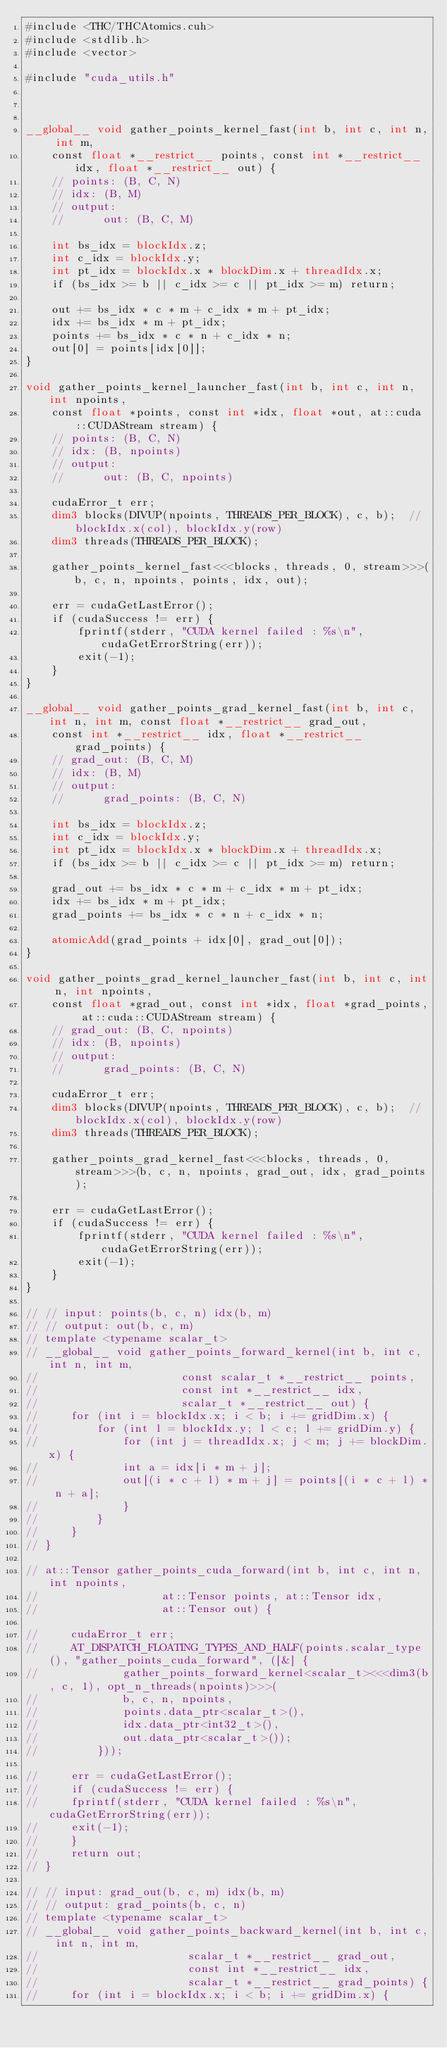Convert code to text. <code><loc_0><loc_0><loc_500><loc_500><_Cuda_>#include <THC/THCAtomics.cuh>
#include <stdlib.h>
#include <vector>

#include "cuda_utils.h"



__global__ void gather_points_kernel_fast(int b, int c, int n, int m,
    const float *__restrict__ points, const int *__restrict__ idx, float *__restrict__ out) {
    // points: (B, C, N)
    // idx: (B, M)
    // output:
    //      out: (B, C, M)

    int bs_idx = blockIdx.z;
    int c_idx = blockIdx.y;
    int pt_idx = blockIdx.x * blockDim.x + threadIdx.x;
    if (bs_idx >= b || c_idx >= c || pt_idx >= m) return;

    out += bs_idx * c * m + c_idx * m + pt_idx;
    idx += bs_idx * m + pt_idx;
    points += bs_idx * c * n + c_idx * n;
    out[0] = points[idx[0]];
}

void gather_points_kernel_launcher_fast(int b, int c, int n, int npoints,
    const float *points, const int *idx, float *out, at::cuda::CUDAStream stream) {
    // points: (B, C, N)
    // idx: (B, npoints)
    // output:
    //      out: (B, C, npoints)

    cudaError_t err;
    dim3 blocks(DIVUP(npoints, THREADS_PER_BLOCK), c, b);  // blockIdx.x(col), blockIdx.y(row)
    dim3 threads(THREADS_PER_BLOCK);

    gather_points_kernel_fast<<<blocks, threads, 0, stream>>>(b, c, n, npoints, points, idx, out);

    err = cudaGetLastError();
    if (cudaSuccess != err) {
        fprintf(stderr, "CUDA kernel failed : %s\n", cudaGetErrorString(err));
        exit(-1);
    }
}

__global__ void gather_points_grad_kernel_fast(int b, int c, int n, int m, const float *__restrict__ grad_out,
    const int *__restrict__ idx, float *__restrict__ grad_points) {
    // grad_out: (B, C, M)
    // idx: (B, M)
    // output:
    //      grad_points: (B, C, N)

    int bs_idx = blockIdx.z;
    int c_idx = blockIdx.y;
    int pt_idx = blockIdx.x * blockDim.x + threadIdx.x;
    if (bs_idx >= b || c_idx >= c || pt_idx >= m) return;

    grad_out += bs_idx * c * m + c_idx * m + pt_idx;
    idx += bs_idx * m + pt_idx;
    grad_points += bs_idx * c * n + c_idx * n;

    atomicAdd(grad_points + idx[0], grad_out[0]);
}

void gather_points_grad_kernel_launcher_fast(int b, int c, int n, int npoints,
    const float *grad_out, const int *idx, float *grad_points, at::cuda::CUDAStream stream) {
    // grad_out: (B, C, npoints)
    // idx: (B, npoints)
    // output:
    //      grad_points: (B, C, N)

    cudaError_t err;
    dim3 blocks(DIVUP(npoints, THREADS_PER_BLOCK), c, b);  // blockIdx.x(col), blockIdx.y(row)
    dim3 threads(THREADS_PER_BLOCK);

    gather_points_grad_kernel_fast<<<blocks, threads, 0, stream>>>(b, c, n, npoints, grad_out, idx, grad_points);

    err = cudaGetLastError();
    if (cudaSuccess != err) {
        fprintf(stderr, "CUDA kernel failed : %s\n", cudaGetErrorString(err));
        exit(-1);
    }
}

// // input: points(b, c, n) idx(b, m)
// // output: out(b, c, m)
// template <typename scalar_t>
// __global__ void gather_points_forward_kernel(int b, int c, int n, int m,
//                      const scalar_t *__restrict__ points,
//                      const int *__restrict__ idx,
//                      scalar_t *__restrict__ out) {
//     for (int i = blockIdx.x; i < b; i += gridDim.x) {
//         for (int l = blockIdx.y; l < c; l += gridDim.y) {
//             for (int j = threadIdx.x; j < m; j += blockDim.x) {
//             int a = idx[i * m + j];
//             out[(i * c + l) * m + j] = points[(i * c + l) * n + a];
//             }
//         }
//     }
// }

// at::Tensor gather_points_cuda_forward(int b, int c, int n, int npoints,
//                   at::Tensor points, at::Tensor idx,
//                   at::Tensor out) {

//     cudaError_t err;
//     AT_DISPATCH_FLOATING_TYPES_AND_HALF(points.scalar_type(), "gather_points_cuda_forward", ([&] {
//             gather_points_forward_kernel<scalar_t><<<dim3(b, c, 1), opt_n_threads(npoints)>>>(
//             b, c, n, npoints,
//             points.data_ptr<scalar_t>(),
//             idx.data_ptr<int32_t>(),
//             out.data_ptr<scalar_t>());
//         }));

//     err = cudaGetLastError();
//     if (cudaSuccess != err) {
//     fprintf(stderr, "CUDA kernel failed : %s\n", cudaGetErrorString(err));
//     exit(-1);
//     }
//     return out;
// }

// // input: grad_out(b, c, m) idx(b, m)
// // output: grad_points(b, c, n)
// template <typename scalar_t>
// __global__ void gather_points_backward_kernel(int b, int c, int n, int m,
//                       scalar_t *__restrict__ grad_out,
//                       const int *__restrict__ idx,
//                       scalar_t *__restrict__ grad_points) {
//     for (int i = blockIdx.x; i < b; i += gridDim.x) {</code> 